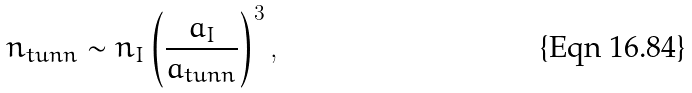Convert formula to latex. <formula><loc_0><loc_0><loc_500><loc_500>n _ { t u n n } \sim n _ { I } \left ( \frac { a _ { I } } { a _ { t u n n } } \right ) ^ { 3 } ,</formula> 